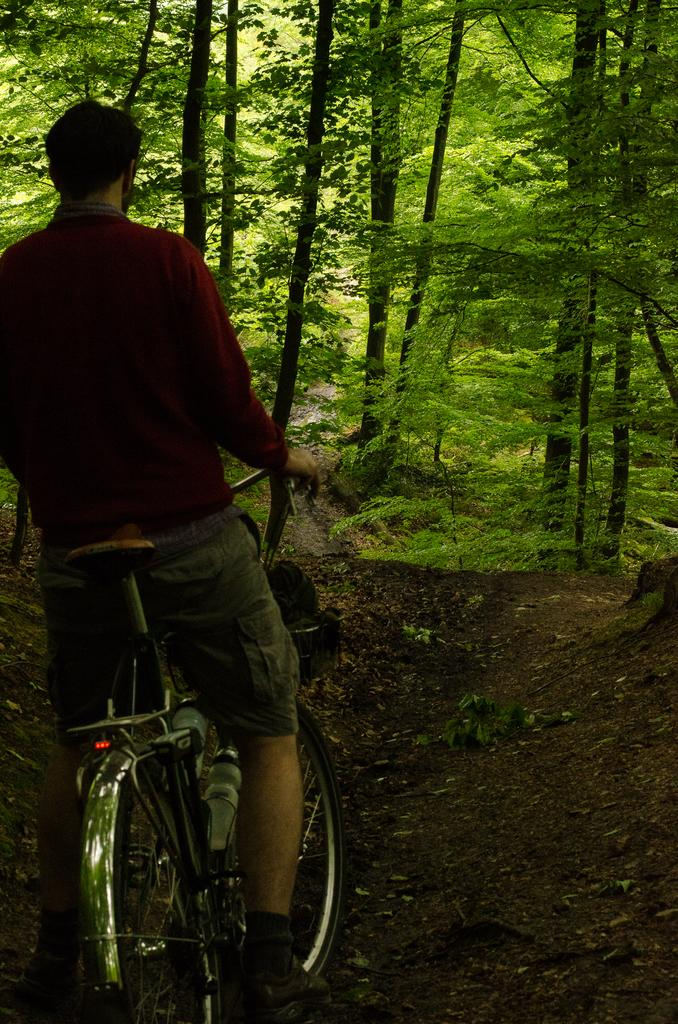What is the main subject of the image? There is a person in the image. What is the person holding in the image? The person is holding a cycle. What can be seen in the background of the image? There are trees in the background of the image. What type of toothbrush is the person using while holding the cycle in the image? There is no toothbrush present in the image, and the person is not using one. 